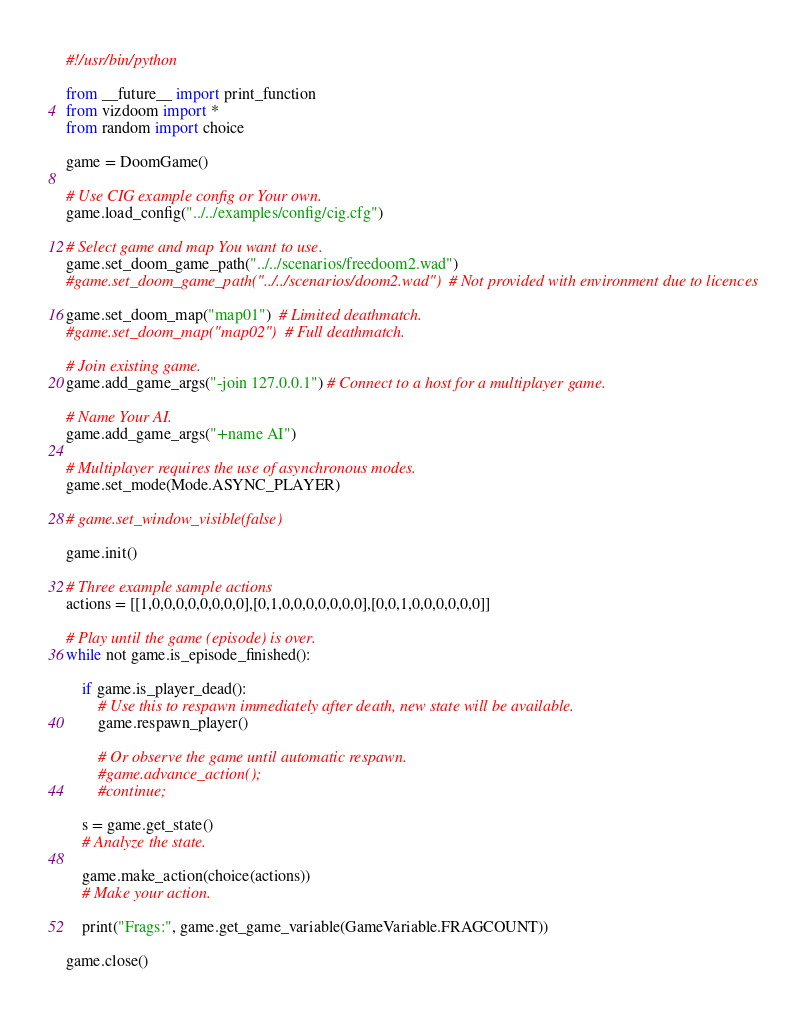<code> <loc_0><loc_0><loc_500><loc_500><_Python_>#!/usr/bin/python

from __future__ import print_function
from vizdoom import *
from random import choice

game = DoomGame()

# Use CIG example config or Your own.
game.load_config("../../examples/config/cig.cfg")

# Select game and map You want to use.
game.set_doom_game_path("../../scenarios/freedoom2.wad")
#game.set_doom_game_path("../../scenarios/doom2.wad")  # Not provided with environment due to licences

game.set_doom_map("map01")  # Limited deathmatch.
#game.set_doom_map("map02")  # Full deathmatch.

# Join existing game.
game.add_game_args("-join 127.0.0.1") # Connect to a host for a multiplayer game.

# Name Your AI.
game.add_game_args("+name AI")

# Multiplayer requires the use of asynchronous modes.
game.set_mode(Mode.ASYNC_PLAYER)

# game.set_window_visible(false)

game.init()

# Three example sample actions
actions = [[1,0,0,0,0,0,0,0,0],[0,1,0,0,0,0,0,0,0],[0,0,1,0,0,0,0,0,0]]

# Play until the game (episode) is over.
while not game.is_episode_finished():

    if game.is_player_dead():
        # Use this to respawn immediately after death, new state will be available.
        game.respawn_player()

        # Or observe the game until automatic respawn.
        #game.advance_action();
        #continue;

    s = game.get_state()
    # Analyze the state.

    game.make_action(choice(actions))
    # Make your action.

    print("Frags:", game.get_game_variable(GameVariable.FRAGCOUNT))

game.close()
</code> 